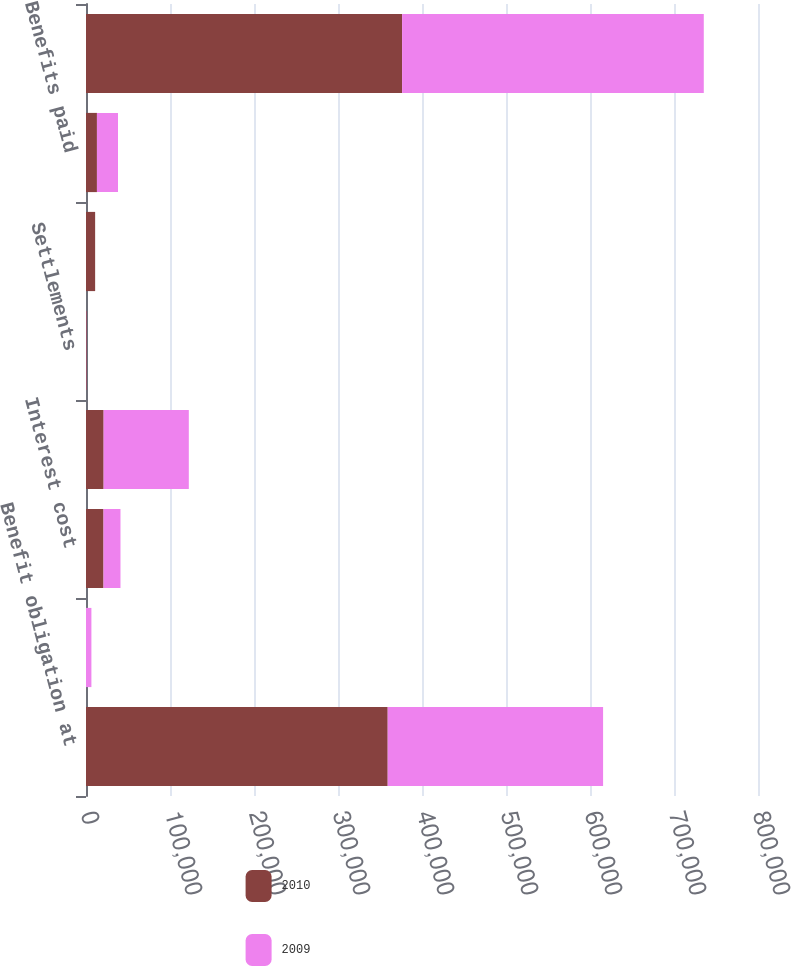<chart> <loc_0><loc_0><loc_500><loc_500><stacked_bar_chart><ecel><fcel>Benefit obligation at<fcel>Service cost<fcel>Interest cost<fcel>Actuarial (gain) loss<fcel>Settlements<fcel>Plan amendments (1)<fcel>Benefits paid<fcel>Benefit obligation at end of<nl><fcel>2010<fcel>359167<fcel>0<fcel>20858<fcel>20994<fcel>826<fcel>10882<fcel>13020<fcel>376291<nl><fcel>2009<fcel>256414<fcel>6430<fcel>20189<fcel>101410<fcel>204<fcel>0<fcel>25072<fcel>359167<nl></chart> 